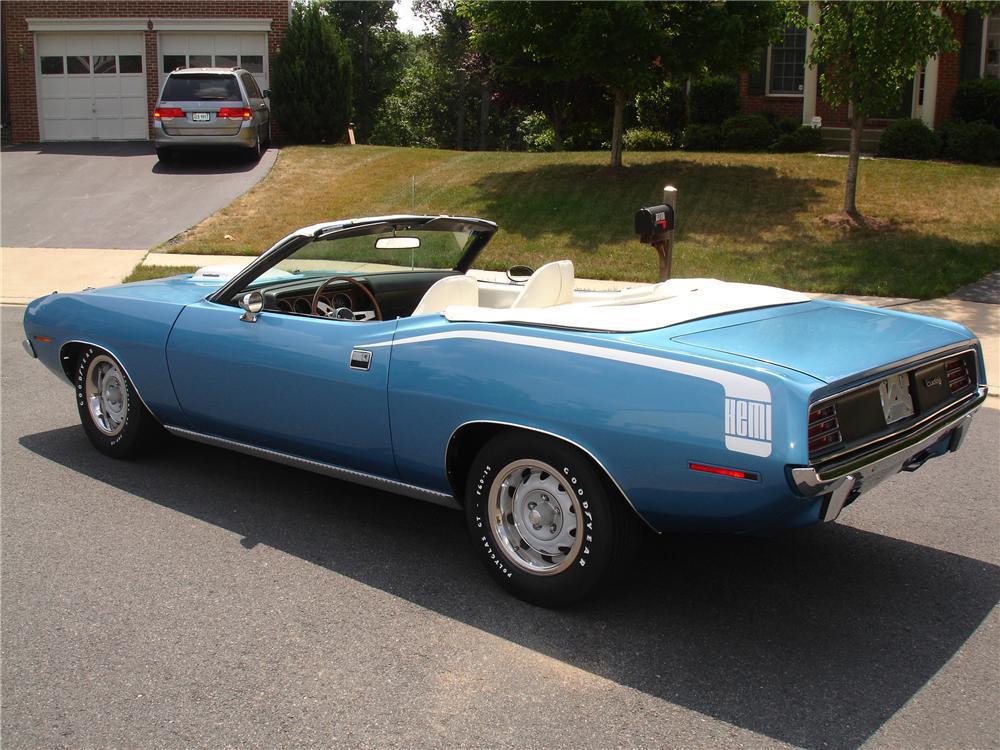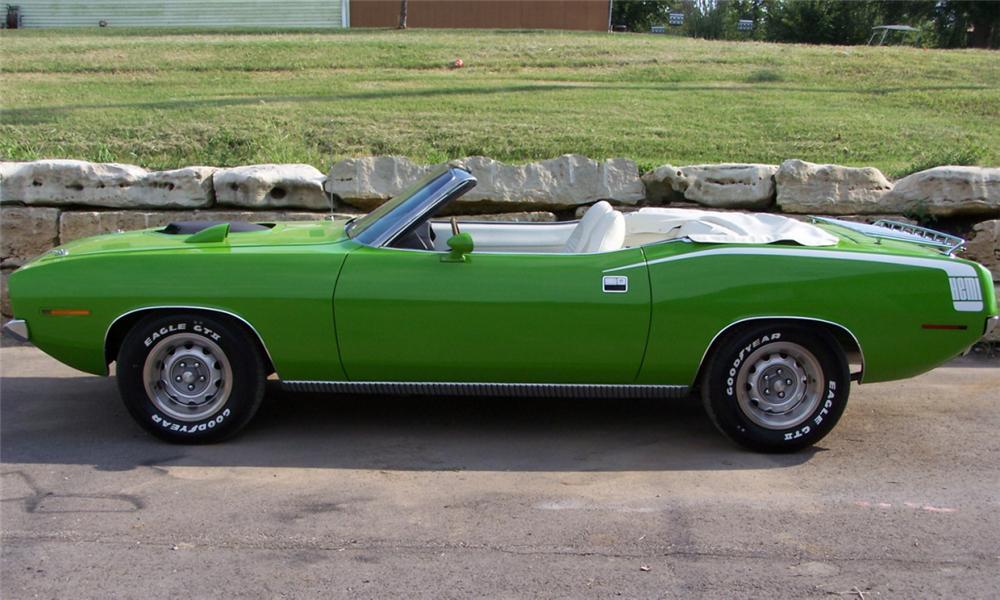The first image is the image on the left, the second image is the image on the right. Considering the images on both sides, is "At least one image shows a car with a white interior and white decal over the rear fender." valid? Answer yes or no. Yes. 